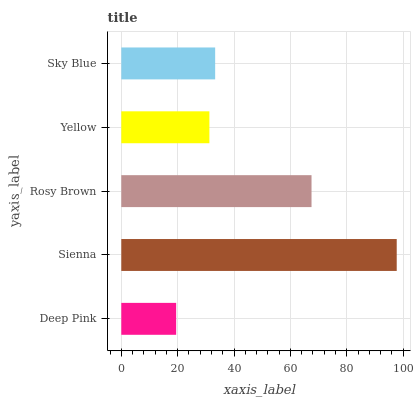Is Deep Pink the minimum?
Answer yes or no. Yes. Is Sienna the maximum?
Answer yes or no. Yes. Is Rosy Brown the minimum?
Answer yes or no. No. Is Rosy Brown the maximum?
Answer yes or no. No. Is Sienna greater than Rosy Brown?
Answer yes or no. Yes. Is Rosy Brown less than Sienna?
Answer yes or no. Yes. Is Rosy Brown greater than Sienna?
Answer yes or no. No. Is Sienna less than Rosy Brown?
Answer yes or no. No. Is Sky Blue the high median?
Answer yes or no. Yes. Is Sky Blue the low median?
Answer yes or no. Yes. Is Sienna the high median?
Answer yes or no. No. Is Sienna the low median?
Answer yes or no. No. 